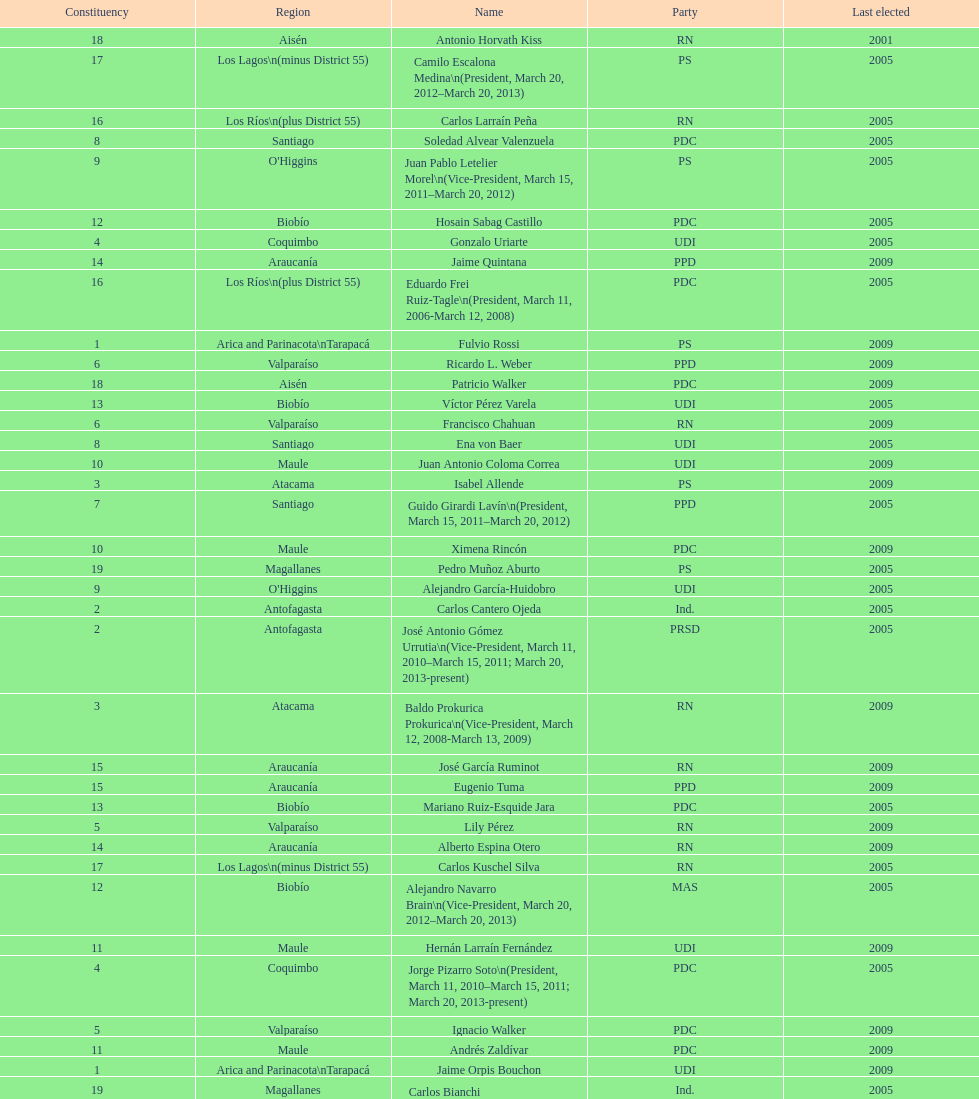Would you mind parsing the complete table? {'header': ['Constituency', 'Region', 'Name', 'Party', 'Last elected'], 'rows': [['18', 'Aisén', 'Antonio Horvath Kiss', 'RN', '2001'], ['17', 'Los Lagos\\n(minus District 55)', 'Camilo Escalona Medina\\n(President, March 20, 2012–March 20, 2013)', 'PS', '2005'], ['16', 'Los Ríos\\n(plus District 55)', 'Carlos Larraín Peña', 'RN', '2005'], ['8', 'Santiago', 'Soledad Alvear Valenzuela', 'PDC', '2005'], ['9', "O'Higgins", 'Juan Pablo Letelier Morel\\n(Vice-President, March 15, 2011–March 20, 2012)', 'PS', '2005'], ['12', 'Biobío', 'Hosain Sabag Castillo', 'PDC', '2005'], ['4', 'Coquimbo', 'Gonzalo Uriarte', 'UDI', '2005'], ['14', 'Araucanía', 'Jaime Quintana', 'PPD', '2009'], ['16', 'Los Ríos\\n(plus District 55)', 'Eduardo Frei Ruiz-Tagle\\n(President, March 11, 2006-March 12, 2008)', 'PDC', '2005'], ['1', 'Arica and Parinacota\\nTarapacá', 'Fulvio Rossi', 'PS', '2009'], ['6', 'Valparaíso', 'Ricardo L. Weber', 'PPD', '2009'], ['18', 'Aisén', 'Patricio Walker', 'PDC', '2009'], ['13', 'Biobío', 'Víctor Pérez Varela', 'UDI', '2005'], ['6', 'Valparaíso', 'Francisco Chahuan', 'RN', '2009'], ['8', 'Santiago', 'Ena von Baer', 'UDI', '2005'], ['10', 'Maule', 'Juan Antonio Coloma Correa', 'UDI', '2009'], ['3', 'Atacama', 'Isabel Allende', 'PS', '2009'], ['7', 'Santiago', 'Guido Girardi Lavín\\n(President, March 15, 2011–March 20, 2012)', 'PPD', '2005'], ['10', 'Maule', 'Ximena Rincón', 'PDC', '2009'], ['19', 'Magallanes', 'Pedro Muñoz Aburto', 'PS', '2005'], ['9', "O'Higgins", 'Alejandro García-Huidobro', 'UDI', '2005'], ['2', 'Antofagasta', 'Carlos Cantero Ojeda', 'Ind.', '2005'], ['2', 'Antofagasta', 'José Antonio Gómez Urrutia\\n(Vice-President, March 11, 2010–March 15, 2011; March 20, 2013-present)', 'PRSD', '2005'], ['3', 'Atacama', 'Baldo Prokurica Prokurica\\n(Vice-President, March 12, 2008-March 13, 2009)', 'RN', '2009'], ['15', 'Araucanía', 'José García Ruminot', 'RN', '2009'], ['15', 'Araucanía', 'Eugenio Tuma', 'PPD', '2009'], ['13', 'Biobío', 'Mariano Ruiz-Esquide Jara', 'PDC', '2005'], ['5', 'Valparaíso', 'Lily Pérez', 'RN', '2009'], ['14', 'Araucanía', 'Alberto Espina Otero', 'RN', '2009'], ['17', 'Los Lagos\\n(minus District 55)', 'Carlos Kuschel Silva', 'RN', '2005'], ['12', 'Biobío', 'Alejandro Navarro Brain\\n(Vice-President, March 20, 2012–March 20, 2013)', 'MAS', '2005'], ['11', 'Maule', 'Hernán Larraín Fernández', 'UDI', '2009'], ['4', 'Coquimbo', 'Jorge Pizarro Soto\\n(President, March 11, 2010–March 15, 2011; March 20, 2013-present)', 'PDC', '2005'], ['5', 'Valparaíso', 'Ignacio Walker', 'PDC', '2009'], ['11', 'Maule', 'Andrés Zaldívar', 'PDC', '2009'], ['1', 'Arica and Parinacota\\nTarapacá', 'Jaime Orpis Bouchon', 'UDI', '2009'], ['19', 'Magallanes', 'Carlos Bianchi Chelech\\n(Vice-President, March 13, 2009–March 11, 2010)', 'Ind.', '2005'], ['7', 'Santiago', 'Jovino Novoa Vásquez\\n(President, March 13, 2009–March 11, 2010)', 'UDI', '2005']]} Which region is listed below atacama? Coquimbo. 